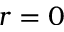<formula> <loc_0><loc_0><loc_500><loc_500>r = 0</formula> 